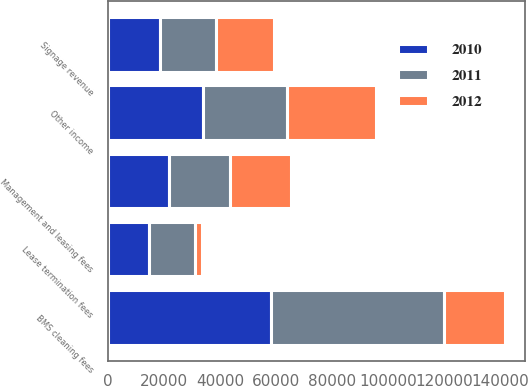<chart> <loc_0><loc_0><loc_500><loc_500><stacked_bar_chart><ecel><fcel>BMS cleaning fees<fcel>Signage revenue<fcel>Management and leasing fees<fcel>Lease termination fees<fcel>Other income<nl><fcel>2012<fcel>21743.5<fcel>20892<fcel>21867<fcel>2361<fcel>31845<nl><fcel>2011<fcel>61754<fcel>19823<fcel>21801<fcel>16334<fcel>30037<nl><fcel>2010<fcel>58053<fcel>18618<fcel>21686<fcel>14818<fcel>33780<nl></chart> 